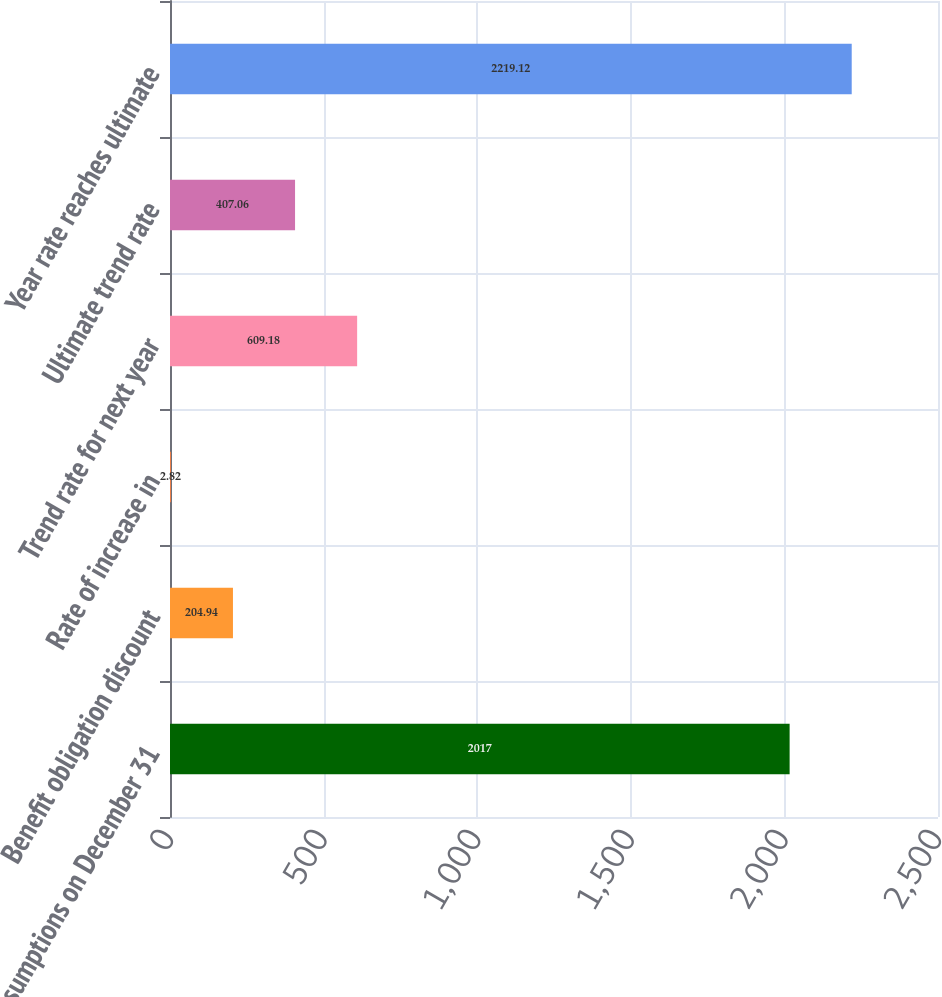Convert chart to OTSL. <chart><loc_0><loc_0><loc_500><loc_500><bar_chart><fcel>Assumptions on December 31<fcel>Benefit obligation discount<fcel>Rate of increase in<fcel>Trend rate for next year<fcel>Ultimate trend rate<fcel>Year rate reaches ultimate<nl><fcel>2017<fcel>204.94<fcel>2.82<fcel>609.18<fcel>407.06<fcel>2219.12<nl></chart> 